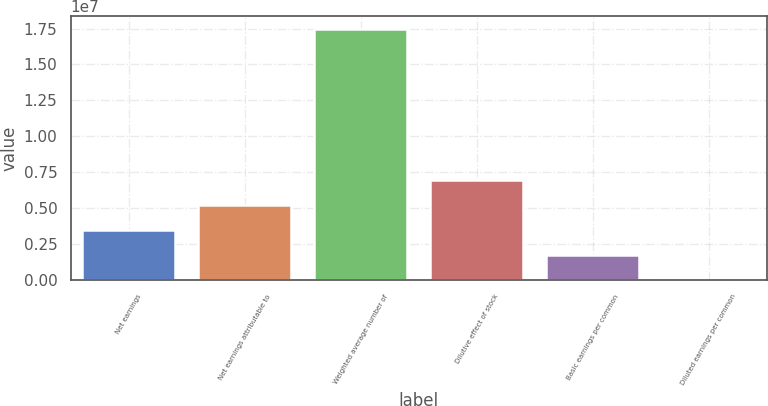Convert chart to OTSL. <chart><loc_0><loc_0><loc_500><loc_500><bar_chart><fcel>Net earnings<fcel>Net earnings attributable to<fcel>Weighted average number of<fcel>Dilutive effect of stock<fcel>Basic earnings per common<fcel>Diluted earnings per common<nl><fcel>3.49322e+06<fcel>5.23984e+06<fcel>1.74661e+07<fcel>6.98645e+06<fcel>1.74661e+06<fcel>1.47<nl></chart> 